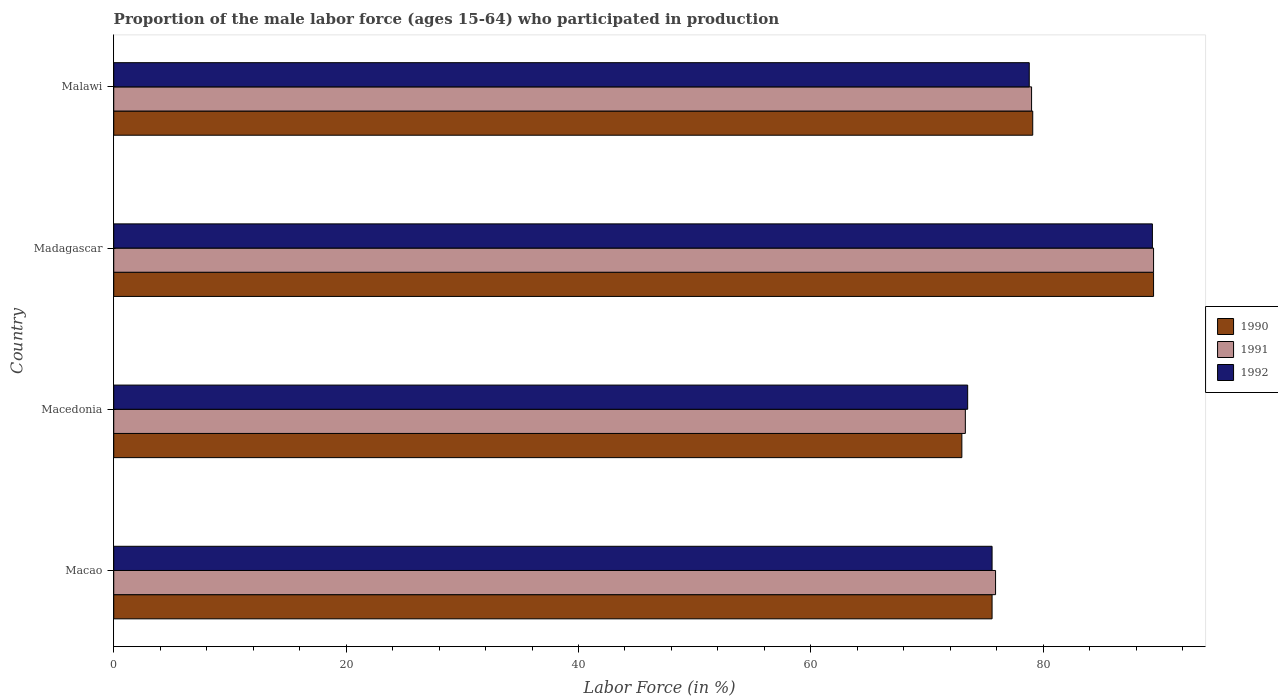How many groups of bars are there?
Keep it short and to the point. 4. Are the number of bars on each tick of the Y-axis equal?
Offer a very short reply. Yes. How many bars are there on the 3rd tick from the top?
Your response must be concise. 3. What is the label of the 4th group of bars from the top?
Your answer should be very brief. Macao. What is the proportion of the male labor force who participated in production in 1992 in Macedonia?
Offer a terse response. 73.5. Across all countries, what is the maximum proportion of the male labor force who participated in production in 1991?
Make the answer very short. 89.5. Across all countries, what is the minimum proportion of the male labor force who participated in production in 1991?
Your answer should be very brief. 73.3. In which country was the proportion of the male labor force who participated in production in 1992 maximum?
Make the answer very short. Madagascar. In which country was the proportion of the male labor force who participated in production in 1992 minimum?
Your answer should be very brief. Macedonia. What is the total proportion of the male labor force who participated in production in 1990 in the graph?
Offer a terse response. 317.2. What is the difference between the proportion of the male labor force who participated in production in 1992 in Macao and that in Macedonia?
Provide a short and direct response. 2.1. What is the difference between the proportion of the male labor force who participated in production in 1990 in Malawi and the proportion of the male labor force who participated in production in 1992 in Madagascar?
Offer a terse response. -10.3. What is the average proportion of the male labor force who participated in production in 1992 per country?
Your answer should be compact. 79.33. What is the difference between the proportion of the male labor force who participated in production in 1992 and proportion of the male labor force who participated in production in 1991 in Madagascar?
Your answer should be very brief. -0.1. In how many countries, is the proportion of the male labor force who participated in production in 1992 greater than 84 %?
Provide a succinct answer. 1. What is the ratio of the proportion of the male labor force who participated in production in 1991 in Macao to that in Malawi?
Give a very brief answer. 0.96. Is the difference between the proportion of the male labor force who participated in production in 1992 in Macedonia and Madagascar greater than the difference between the proportion of the male labor force who participated in production in 1991 in Macedonia and Madagascar?
Provide a succinct answer. Yes. What is the difference between the highest and the second highest proportion of the male labor force who participated in production in 1992?
Keep it short and to the point. 10.6. What is the difference between the highest and the lowest proportion of the male labor force who participated in production in 1990?
Keep it short and to the point. 16.5. In how many countries, is the proportion of the male labor force who participated in production in 1990 greater than the average proportion of the male labor force who participated in production in 1990 taken over all countries?
Your response must be concise. 1. Is the sum of the proportion of the male labor force who participated in production in 1992 in Macao and Malawi greater than the maximum proportion of the male labor force who participated in production in 1990 across all countries?
Your answer should be very brief. Yes. What does the 1st bar from the top in Macao represents?
Your answer should be very brief. 1992. Are all the bars in the graph horizontal?
Your answer should be very brief. Yes. What is the difference between two consecutive major ticks on the X-axis?
Provide a short and direct response. 20. Does the graph contain any zero values?
Offer a terse response. No. Does the graph contain grids?
Make the answer very short. No. What is the title of the graph?
Ensure brevity in your answer.  Proportion of the male labor force (ages 15-64) who participated in production. What is the label or title of the X-axis?
Offer a terse response. Labor Force (in %). What is the label or title of the Y-axis?
Give a very brief answer. Country. What is the Labor Force (in %) of 1990 in Macao?
Keep it short and to the point. 75.6. What is the Labor Force (in %) in 1991 in Macao?
Your response must be concise. 75.9. What is the Labor Force (in %) of 1992 in Macao?
Your answer should be compact. 75.6. What is the Labor Force (in %) in 1990 in Macedonia?
Ensure brevity in your answer.  73. What is the Labor Force (in %) in 1991 in Macedonia?
Give a very brief answer. 73.3. What is the Labor Force (in %) in 1992 in Macedonia?
Give a very brief answer. 73.5. What is the Labor Force (in %) of 1990 in Madagascar?
Keep it short and to the point. 89.5. What is the Labor Force (in %) of 1991 in Madagascar?
Offer a very short reply. 89.5. What is the Labor Force (in %) in 1992 in Madagascar?
Make the answer very short. 89.4. What is the Labor Force (in %) in 1990 in Malawi?
Keep it short and to the point. 79.1. What is the Labor Force (in %) of 1991 in Malawi?
Your response must be concise. 79. What is the Labor Force (in %) in 1992 in Malawi?
Your answer should be very brief. 78.8. Across all countries, what is the maximum Labor Force (in %) of 1990?
Your answer should be very brief. 89.5. Across all countries, what is the maximum Labor Force (in %) of 1991?
Offer a terse response. 89.5. Across all countries, what is the maximum Labor Force (in %) of 1992?
Ensure brevity in your answer.  89.4. Across all countries, what is the minimum Labor Force (in %) in 1991?
Provide a short and direct response. 73.3. Across all countries, what is the minimum Labor Force (in %) of 1992?
Provide a short and direct response. 73.5. What is the total Labor Force (in %) in 1990 in the graph?
Give a very brief answer. 317.2. What is the total Labor Force (in %) in 1991 in the graph?
Provide a succinct answer. 317.7. What is the total Labor Force (in %) of 1992 in the graph?
Offer a very short reply. 317.3. What is the difference between the Labor Force (in %) of 1990 in Macao and that in Macedonia?
Your answer should be very brief. 2.6. What is the difference between the Labor Force (in %) of 1991 in Macao and that in Madagascar?
Offer a terse response. -13.6. What is the difference between the Labor Force (in %) in 1990 in Macedonia and that in Madagascar?
Your answer should be compact. -16.5. What is the difference between the Labor Force (in %) of 1991 in Macedonia and that in Madagascar?
Provide a succinct answer. -16.2. What is the difference between the Labor Force (in %) of 1992 in Macedonia and that in Madagascar?
Provide a succinct answer. -15.9. What is the difference between the Labor Force (in %) in 1991 in Macedonia and that in Malawi?
Offer a terse response. -5.7. What is the difference between the Labor Force (in %) in 1991 in Macao and the Labor Force (in %) in 1992 in Macedonia?
Ensure brevity in your answer.  2.4. What is the difference between the Labor Force (in %) in 1990 in Macao and the Labor Force (in %) in 1992 in Madagascar?
Provide a short and direct response. -13.8. What is the difference between the Labor Force (in %) of 1991 in Macao and the Labor Force (in %) of 1992 in Madagascar?
Give a very brief answer. -13.5. What is the difference between the Labor Force (in %) of 1991 in Macao and the Labor Force (in %) of 1992 in Malawi?
Give a very brief answer. -2.9. What is the difference between the Labor Force (in %) of 1990 in Macedonia and the Labor Force (in %) of 1991 in Madagascar?
Ensure brevity in your answer.  -16.5. What is the difference between the Labor Force (in %) in 1990 in Macedonia and the Labor Force (in %) in 1992 in Madagascar?
Ensure brevity in your answer.  -16.4. What is the difference between the Labor Force (in %) in 1991 in Macedonia and the Labor Force (in %) in 1992 in Madagascar?
Your answer should be compact. -16.1. What is the difference between the Labor Force (in %) in 1990 in Macedonia and the Labor Force (in %) in 1991 in Malawi?
Your answer should be compact. -6. What is the difference between the Labor Force (in %) of 1990 in Macedonia and the Labor Force (in %) of 1992 in Malawi?
Provide a succinct answer. -5.8. What is the difference between the Labor Force (in %) of 1990 in Madagascar and the Labor Force (in %) of 1991 in Malawi?
Keep it short and to the point. 10.5. What is the difference between the Labor Force (in %) in 1991 in Madagascar and the Labor Force (in %) in 1992 in Malawi?
Provide a succinct answer. 10.7. What is the average Labor Force (in %) in 1990 per country?
Provide a short and direct response. 79.3. What is the average Labor Force (in %) in 1991 per country?
Keep it short and to the point. 79.42. What is the average Labor Force (in %) in 1992 per country?
Your answer should be very brief. 79.33. What is the difference between the Labor Force (in %) in 1990 and Labor Force (in %) in 1991 in Macedonia?
Give a very brief answer. -0.3. What is the difference between the Labor Force (in %) in 1990 and Labor Force (in %) in 1992 in Macedonia?
Provide a short and direct response. -0.5. What is the difference between the Labor Force (in %) in 1990 and Labor Force (in %) in 1992 in Madagascar?
Make the answer very short. 0.1. What is the difference between the Labor Force (in %) of 1990 and Labor Force (in %) of 1991 in Malawi?
Provide a succinct answer. 0.1. What is the ratio of the Labor Force (in %) in 1990 in Macao to that in Macedonia?
Provide a short and direct response. 1.04. What is the ratio of the Labor Force (in %) of 1991 in Macao to that in Macedonia?
Provide a short and direct response. 1.04. What is the ratio of the Labor Force (in %) of 1992 in Macao to that in Macedonia?
Offer a terse response. 1.03. What is the ratio of the Labor Force (in %) in 1990 in Macao to that in Madagascar?
Keep it short and to the point. 0.84. What is the ratio of the Labor Force (in %) in 1991 in Macao to that in Madagascar?
Provide a short and direct response. 0.85. What is the ratio of the Labor Force (in %) of 1992 in Macao to that in Madagascar?
Provide a short and direct response. 0.85. What is the ratio of the Labor Force (in %) in 1990 in Macao to that in Malawi?
Your answer should be compact. 0.96. What is the ratio of the Labor Force (in %) in 1991 in Macao to that in Malawi?
Ensure brevity in your answer.  0.96. What is the ratio of the Labor Force (in %) of 1992 in Macao to that in Malawi?
Provide a short and direct response. 0.96. What is the ratio of the Labor Force (in %) in 1990 in Macedonia to that in Madagascar?
Ensure brevity in your answer.  0.82. What is the ratio of the Labor Force (in %) of 1991 in Macedonia to that in Madagascar?
Offer a very short reply. 0.82. What is the ratio of the Labor Force (in %) in 1992 in Macedonia to that in Madagascar?
Make the answer very short. 0.82. What is the ratio of the Labor Force (in %) of 1990 in Macedonia to that in Malawi?
Your response must be concise. 0.92. What is the ratio of the Labor Force (in %) of 1991 in Macedonia to that in Malawi?
Provide a short and direct response. 0.93. What is the ratio of the Labor Force (in %) in 1992 in Macedonia to that in Malawi?
Make the answer very short. 0.93. What is the ratio of the Labor Force (in %) in 1990 in Madagascar to that in Malawi?
Ensure brevity in your answer.  1.13. What is the ratio of the Labor Force (in %) in 1991 in Madagascar to that in Malawi?
Provide a short and direct response. 1.13. What is the ratio of the Labor Force (in %) in 1992 in Madagascar to that in Malawi?
Give a very brief answer. 1.13. What is the difference between the highest and the second highest Labor Force (in %) in 1992?
Make the answer very short. 10.6. What is the difference between the highest and the lowest Labor Force (in %) in 1992?
Your answer should be very brief. 15.9. 